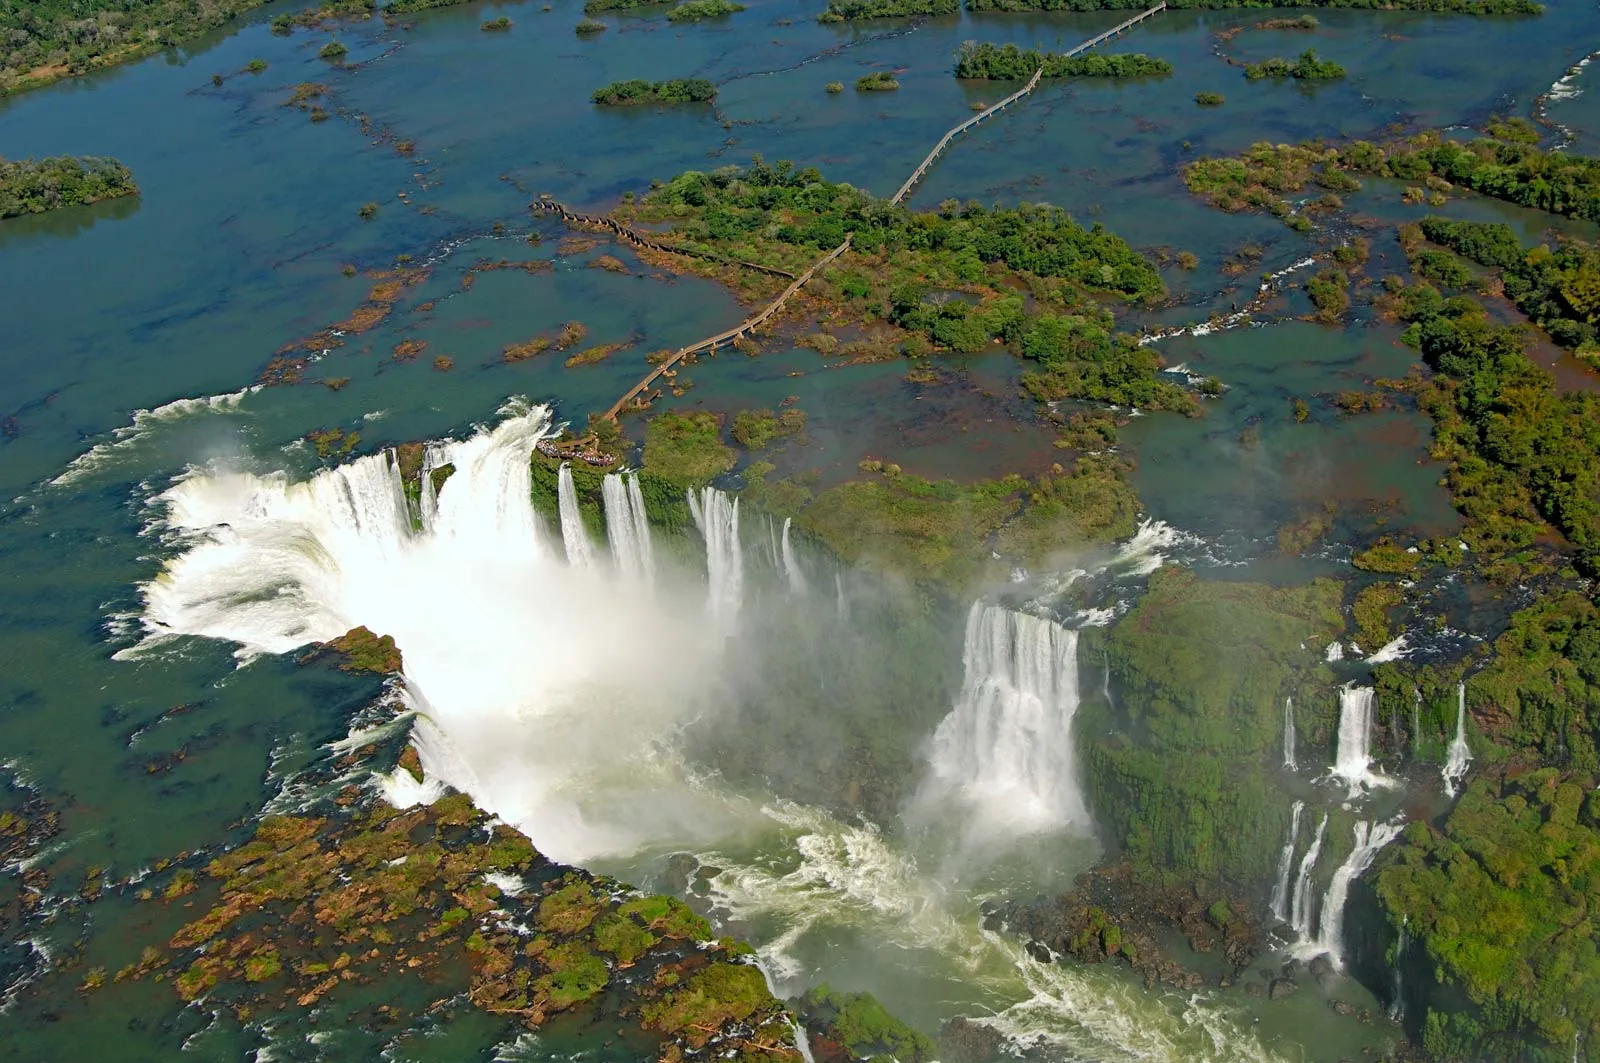Can you describe the impact of these falls on the surrounding environment? The Iguazu Falls significantly influence the surrounding ecosystem. The constant mist generated by the falls creates a unique microclimate that supports a diverse range of flora and fauna. This mist encourages lush vegetation growth, which in turn provides habitat for various wildlife species, including rare and endangered animals. The river system itself is a critical water source for the region, supporting both terrestrial and aquatic life. Overall, the falls contribute to a rich and vibrant ecosystem, making it a vital natural sanctuary. 